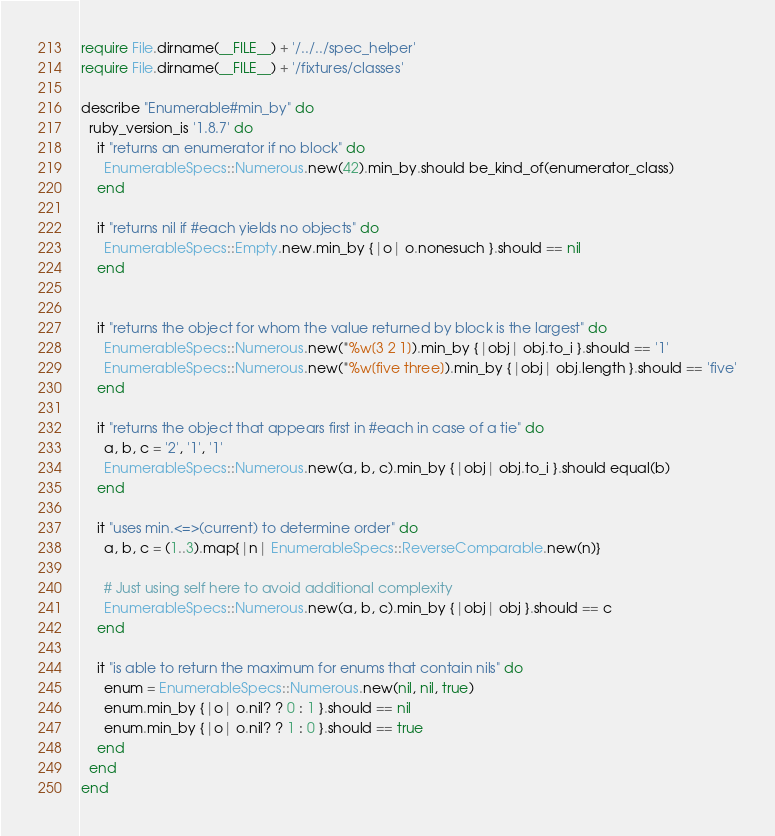Convert code to text. <code><loc_0><loc_0><loc_500><loc_500><_Ruby_>require File.dirname(__FILE__) + '/../../spec_helper'
require File.dirname(__FILE__) + '/fixtures/classes'

describe "Enumerable#min_by" do
  ruby_version_is '1.8.7' do
    it "returns an enumerator if no block" do
      EnumerableSpecs::Numerous.new(42).min_by.should be_kind_of(enumerator_class)
    end

    it "returns nil if #each yields no objects" do
      EnumerableSpecs::Empty.new.min_by {|o| o.nonesuch }.should == nil
    end


    it "returns the object for whom the value returned by block is the largest" do
      EnumerableSpecs::Numerous.new(*%w[3 2 1]).min_by {|obj| obj.to_i }.should == '1'
      EnumerableSpecs::Numerous.new(*%w[five three]).min_by {|obj| obj.length }.should == 'five'
    end

    it "returns the object that appears first in #each in case of a tie" do
      a, b, c = '2', '1', '1'
      EnumerableSpecs::Numerous.new(a, b, c).min_by {|obj| obj.to_i }.should equal(b)
    end

    it "uses min.<=>(current) to determine order" do
      a, b, c = (1..3).map{|n| EnumerableSpecs::ReverseComparable.new(n)}

      # Just using self here to avoid additional complexity
      EnumerableSpecs::Numerous.new(a, b, c).min_by {|obj| obj }.should == c
    end

    it "is able to return the maximum for enums that contain nils" do
      enum = EnumerableSpecs::Numerous.new(nil, nil, true)
      enum.min_by {|o| o.nil? ? 0 : 1 }.should == nil
      enum.min_by {|o| o.nil? ? 1 : 0 }.should == true
    end
  end
end</code> 